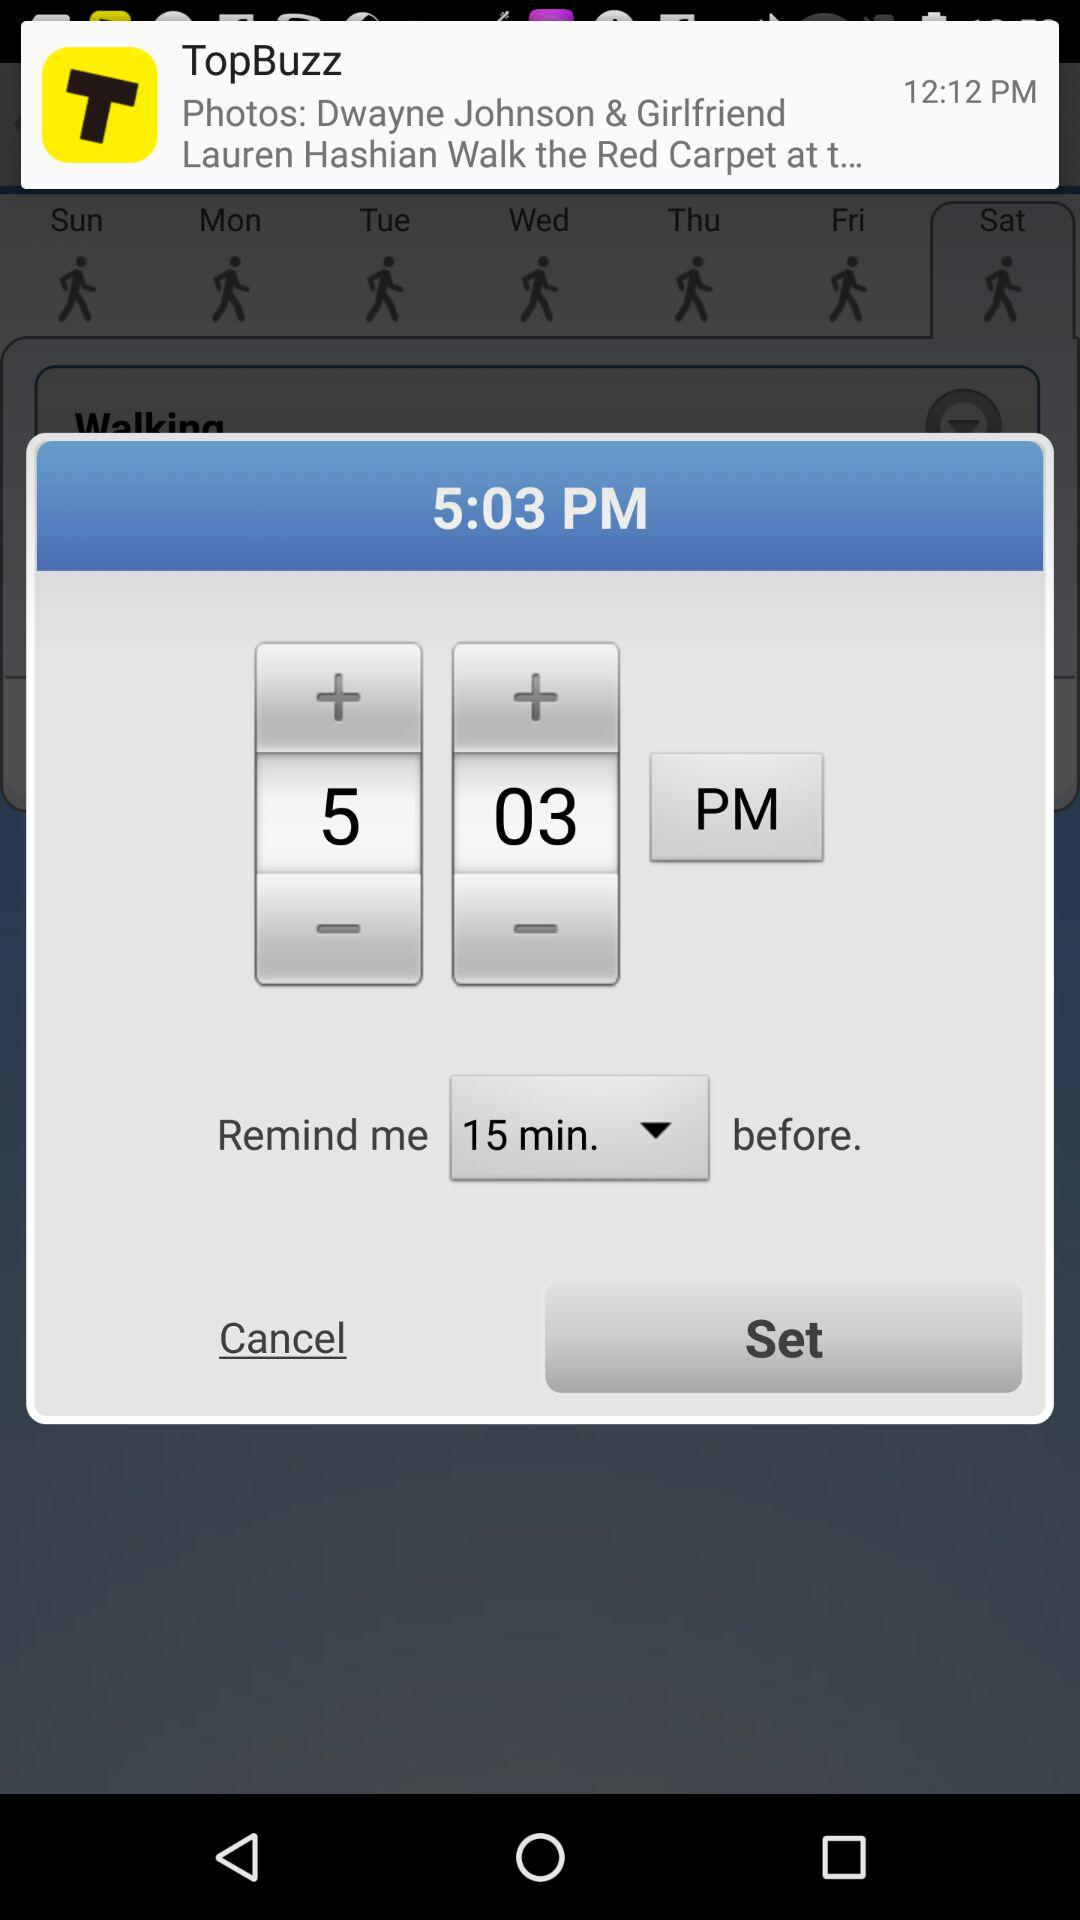How many minutes before is the reminder set for?
Answer the question using a single word or phrase. 15 minutes 